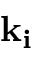<formula> <loc_0><loc_0><loc_500><loc_500>k _ { i }</formula> 